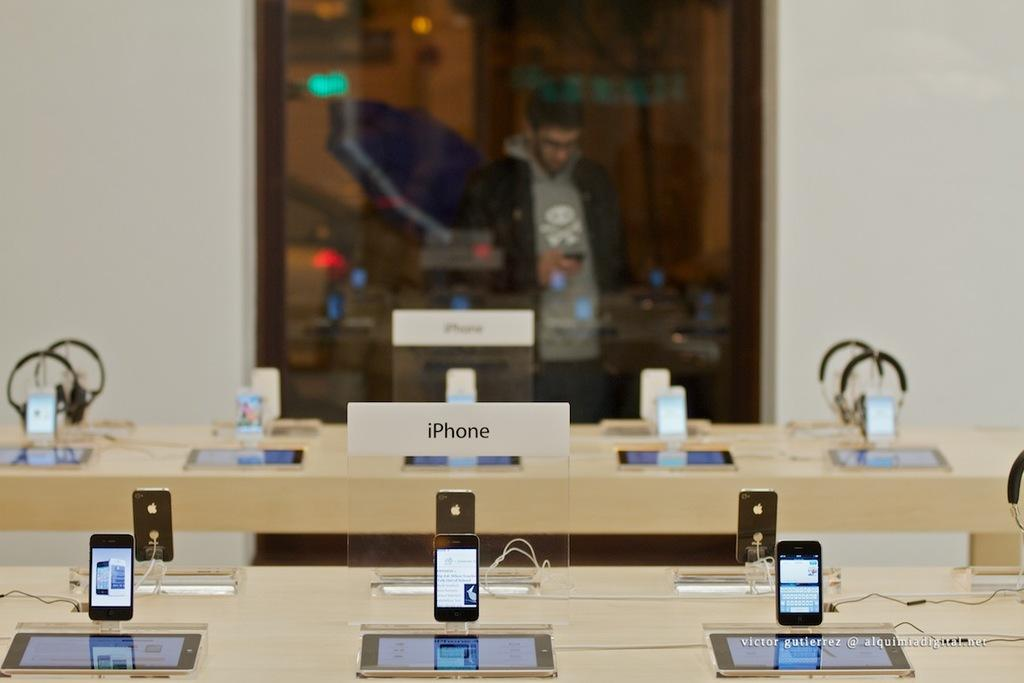<image>
Give a short and clear explanation of the subsequent image. An iphone display has several of them on stands. 